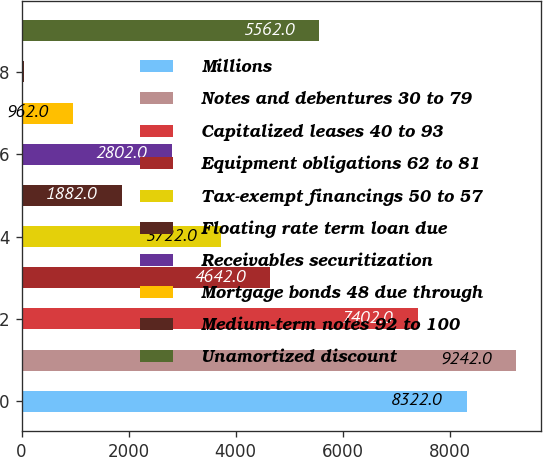<chart> <loc_0><loc_0><loc_500><loc_500><bar_chart><fcel>Millions<fcel>Notes and debentures 30 to 79<fcel>Capitalized leases 40 to 93<fcel>Equipment obligations 62 to 81<fcel>Tax-exempt financings 50 to 57<fcel>Floating rate term loan due<fcel>Receivables securitization<fcel>Mortgage bonds 48 due through<fcel>Medium-term notes 92 to 100<fcel>Unamortized discount<nl><fcel>8322<fcel>9242<fcel>7402<fcel>4642<fcel>3722<fcel>1882<fcel>2802<fcel>962<fcel>42<fcel>5562<nl></chart> 